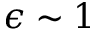<formula> <loc_0><loc_0><loc_500><loc_500>\epsilon \sim 1</formula> 